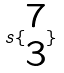Convert formula to latex. <formula><loc_0><loc_0><loc_500><loc_500>s \{ \begin{matrix} 7 \\ 3 \end{matrix} \}</formula> 